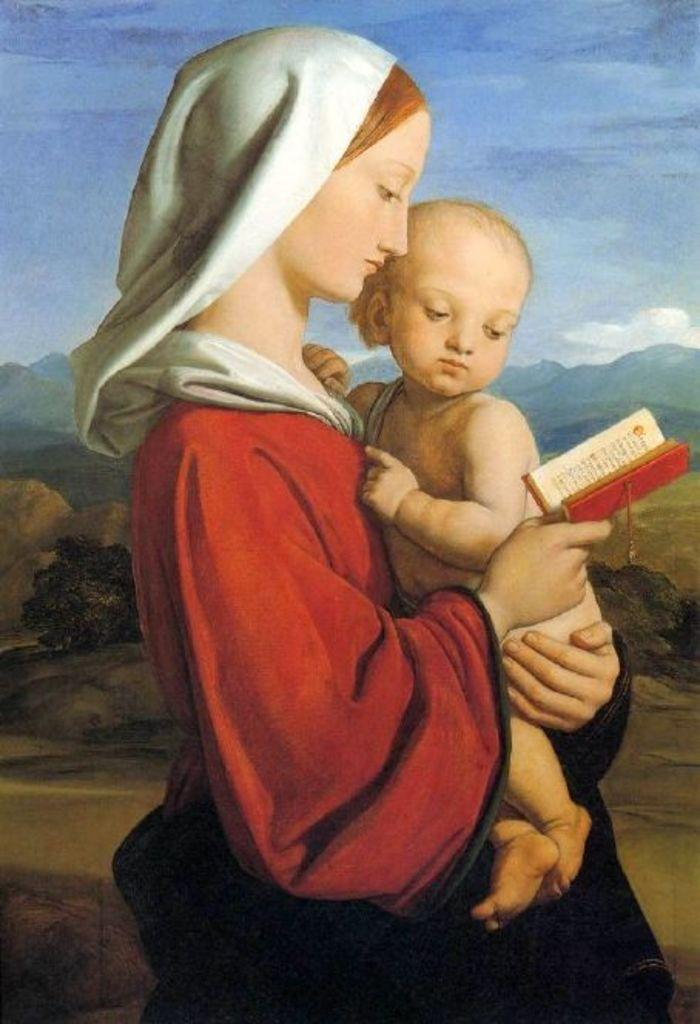What is the main subject of the painting? The painting depicts a woman. What is the woman wearing? The woman is wearing clothes. What is the woman holding in each hand? The woman is holding a child in one hand and a book in the other hand. What type of landscape can be seen in the painting? There are mountains visible in the painting. What part of the natural environment is depicted in the painting? The sky is present in the painting. How many boats can be seen in the painting? There are no boats present in the painting; it features a woman holding a child and a book, with mountains and sky in the background. 